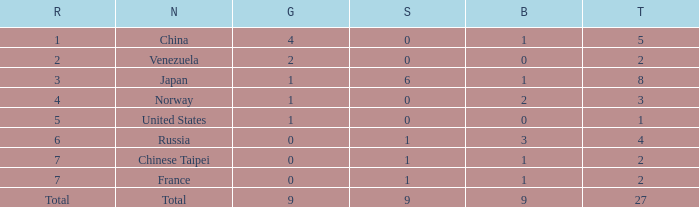What is the sum of Total when rank is 2? 2.0. 